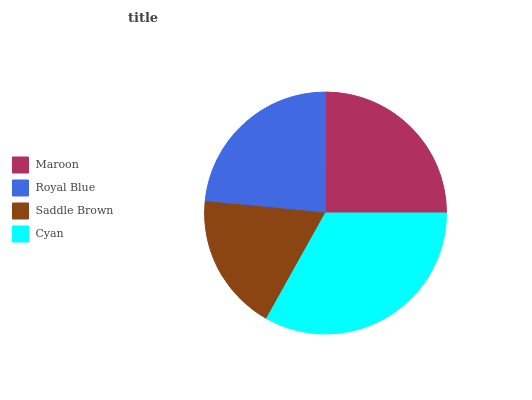Is Saddle Brown the minimum?
Answer yes or no. Yes. Is Cyan the maximum?
Answer yes or no. Yes. Is Royal Blue the minimum?
Answer yes or no. No. Is Royal Blue the maximum?
Answer yes or no. No. Is Maroon greater than Royal Blue?
Answer yes or no. Yes. Is Royal Blue less than Maroon?
Answer yes or no. Yes. Is Royal Blue greater than Maroon?
Answer yes or no. No. Is Maroon less than Royal Blue?
Answer yes or no. No. Is Maroon the high median?
Answer yes or no. Yes. Is Royal Blue the low median?
Answer yes or no. Yes. Is Cyan the high median?
Answer yes or no. No. Is Maroon the low median?
Answer yes or no. No. 